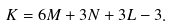<formula> <loc_0><loc_0><loc_500><loc_500>K = 6 M + 3 N + 3 L - 3 .</formula> 